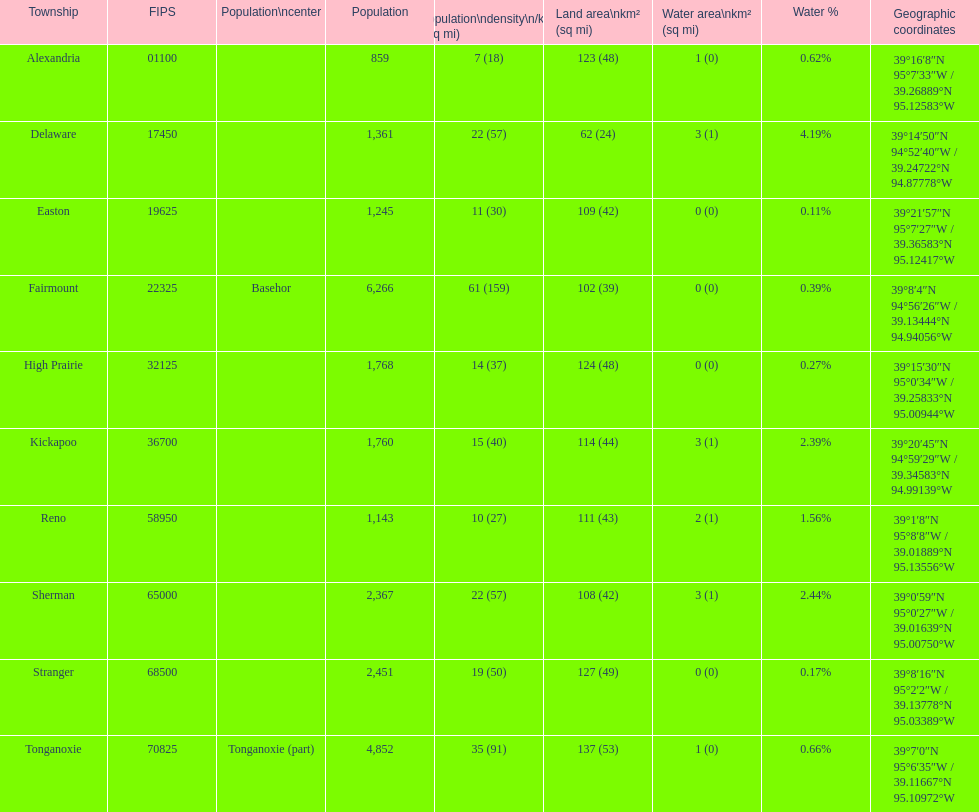Parse the full table. {'header': ['Township', 'FIPS', 'Population\\ncenter', 'Population', 'Population\\ndensity\\n/km² (/sq\xa0mi)', 'Land area\\nkm² (sq\xa0mi)', 'Water area\\nkm² (sq\xa0mi)', 'Water\xa0%', 'Geographic coordinates'], 'rows': [['Alexandria', '01100', '', '859', '7 (18)', '123 (48)', '1 (0)', '0.62%', '39°16′8″N 95°7′33″W\ufeff / \ufeff39.26889°N 95.12583°W'], ['Delaware', '17450', '', '1,361', '22 (57)', '62 (24)', '3 (1)', '4.19%', '39°14′50″N 94°52′40″W\ufeff / \ufeff39.24722°N 94.87778°W'], ['Easton', '19625', '', '1,245', '11 (30)', '109 (42)', '0 (0)', '0.11%', '39°21′57″N 95°7′27″W\ufeff / \ufeff39.36583°N 95.12417°W'], ['Fairmount', '22325', 'Basehor', '6,266', '61 (159)', '102 (39)', '0 (0)', '0.39%', '39°8′4″N 94°56′26″W\ufeff / \ufeff39.13444°N 94.94056°W'], ['High Prairie', '32125', '', '1,768', '14 (37)', '124 (48)', '0 (0)', '0.27%', '39°15′30″N 95°0′34″W\ufeff / \ufeff39.25833°N 95.00944°W'], ['Kickapoo', '36700', '', '1,760', '15 (40)', '114 (44)', '3 (1)', '2.39%', '39°20′45″N 94°59′29″W\ufeff / \ufeff39.34583°N 94.99139°W'], ['Reno', '58950', '', '1,143', '10 (27)', '111 (43)', '2 (1)', '1.56%', '39°1′8″N 95°8′8″W\ufeff / \ufeff39.01889°N 95.13556°W'], ['Sherman', '65000', '', '2,367', '22 (57)', '108 (42)', '3 (1)', '2.44%', '39°0′59″N 95°0′27″W\ufeff / \ufeff39.01639°N 95.00750°W'], ['Stranger', '68500', '', '2,451', '19 (50)', '127 (49)', '0 (0)', '0.17%', '39°8′16″N 95°2′2″W\ufeff / \ufeff39.13778°N 95.03389°W'], ['Tonganoxie', '70825', 'Tonganoxie (part)', '4,852', '35 (91)', '137 (53)', '1 (0)', '0.66%', '39°7′0″N 95°6′35″W\ufeff / \ufeff39.11667°N 95.10972°W']]} Does alexandria county have a higher or lower population than delaware county? Lower. 